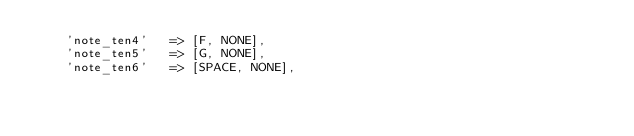Convert code to text. <code><loc_0><loc_0><loc_500><loc_500><_Haxe_>		'note_ten4'		=> [F, NONE],
		'note_ten5'		=> [G, NONE],
		'note_ten6'		=> [SPACE, NONE],</code> 